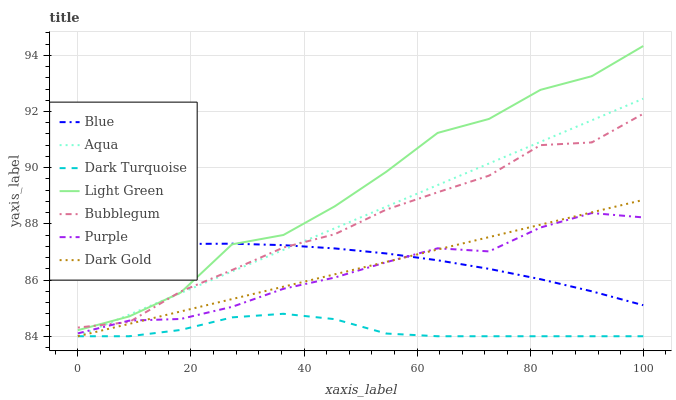Does Dark Turquoise have the minimum area under the curve?
Answer yes or no. Yes. Does Light Green have the maximum area under the curve?
Answer yes or no. Yes. Does Dark Gold have the minimum area under the curve?
Answer yes or no. No. Does Dark Gold have the maximum area under the curve?
Answer yes or no. No. Is Dark Gold the smoothest?
Answer yes or no. Yes. Is Light Green the roughest?
Answer yes or no. Yes. Is Purple the smoothest?
Answer yes or no. No. Is Purple the roughest?
Answer yes or no. No. Does Dark Gold have the lowest value?
Answer yes or no. Yes. Does Purple have the lowest value?
Answer yes or no. No. Does Light Green have the highest value?
Answer yes or no. Yes. Does Dark Gold have the highest value?
Answer yes or no. No. Is Dark Turquoise less than Bubblegum?
Answer yes or no. Yes. Is Bubblegum greater than Dark Gold?
Answer yes or no. Yes. Does Dark Turquoise intersect Aqua?
Answer yes or no. Yes. Is Dark Turquoise less than Aqua?
Answer yes or no. No. Is Dark Turquoise greater than Aqua?
Answer yes or no. No. Does Dark Turquoise intersect Bubblegum?
Answer yes or no. No. 